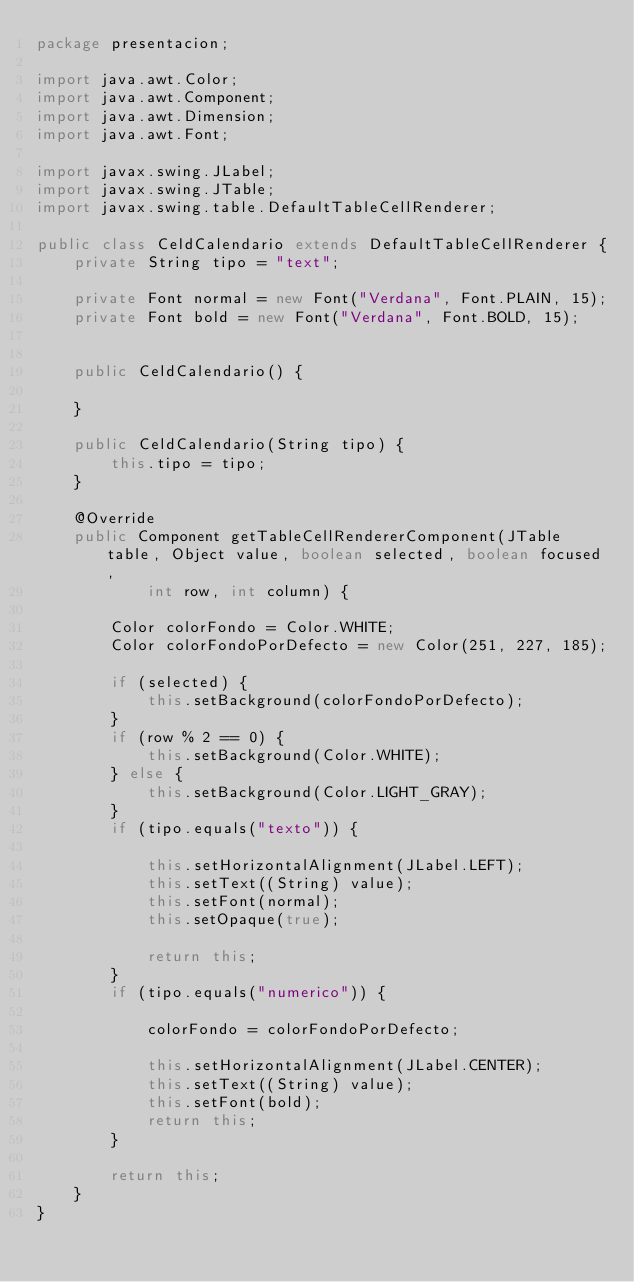<code> <loc_0><loc_0><loc_500><loc_500><_Java_>package presentacion;

import java.awt.Color;
import java.awt.Component;
import java.awt.Dimension;
import java.awt.Font;

import javax.swing.JLabel;
import javax.swing.JTable;
import javax.swing.table.DefaultTableCellRenderer;

public class CeldCalendario extends DefaultTableCellRenderer {
	private String tipo = "text";

	private Font normal = new Font("Verdana", Font.PLAIN, 15);
	private Font bold = new Font("Verdana", Font.BOLD, 15);


	public CeldCalendario() {

	}

	public CeldCalendario(String tipo) {
		this.tipo = tipo;
	}

	@Override
	public Component getTableCellRendererComponent(JTable table, Object value, boolean selected, boolean focused,
			int row, int column) {

		Color colorFondo = Color.WHITE;
		Color colorFondoPorDefecto = new Color(251, 227, 185);

		if (selected) {
			this.setBackground(colorFondoPorDefecto);
		}
		if (row % 2 == 0) {
			this.setBackground(Color.WHITE);
		} else {
			this.setBackground(Color.LIGHT_GRAY);
		}
		if (tipo.equals("texto")) {

			this.setHorizontalAlignment(JLabel.LEFT);
			this.setText((String) value);
			this.setFont(normal);
			this.setOpaque(true);

			return this;
		}
		if (tipo.equals("numerico")) {

			colorFondo = colorFondoPorDefecto;

			this.setHorizontalAlignment(JLabel.CENTER);
			this.setText((String) value);
			this.setFont(bold);
			return this;
		}

		return this;
	}
}
</code> 